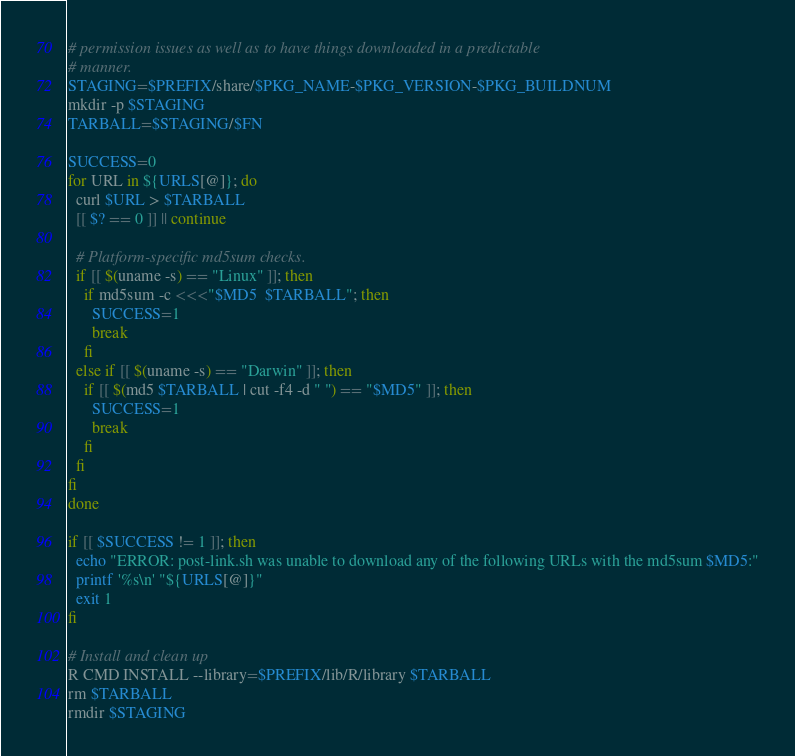<code> <loc_0><loc_0><loc_500><loc_500><_Bash_># permission issues as well as to have things downloaded in a predictable
# manner.
STAGING=$PREFIX/share/$PKG_NAME-$PKG_VERSION-$PKG_BUILDNUM
mkdir -p $STAGING
TARBALL=$STAGING/$FN

SUCCESS=0
for URL in ${URLS[@]}; do
  curl $URL > $TARBALL
  [[ $? == 0 ]] || continue

  # Platform-specific md5sum checks.
  if [[ $(uname -s) == "Linux" ]]; then
    if md5sum -c <<<"$MD5  $TARBALL"; then
      SUCCESS=1
      break
    fi
  else if [[ $(uname -s) == "Darwin" ]]; then
    if [[ $(md5 $TARBALL | cut -f4 -d " ") == "$MD5" ]]; then
      SUCCESS=1
      break
    fi
  fi
fi
done

if [[ $SUCCESS != 1 ]]; then
  echo "ERROR: post-link.sh was unable to download any of the following URLs with the md5sum $MD5:"
  printf '%s\n' "${URLS[@]}"
  exit 1
fi

# Install and clean up
R CMD INSTALL --library=$PREFIX/lib/R/library $TARBALL
rm $TARBALL
rmdir $STAGING
</code> 